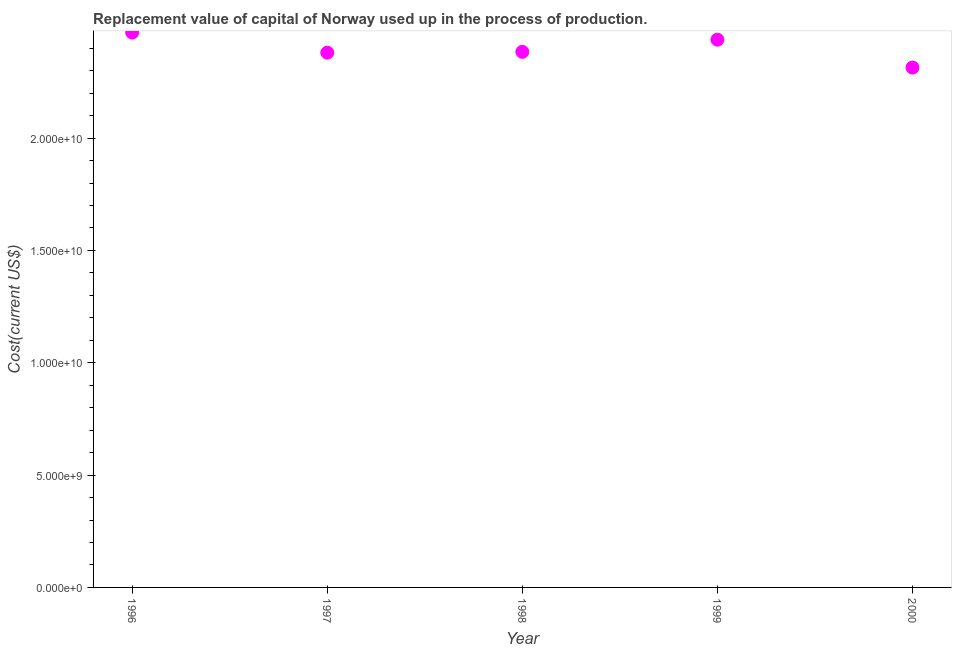What is the consumption of fixed capital in 1997?
Provide a short and direct response. 2.38e+1. Across all years, what is the maximum consumption of fixed capital?
Provide a succinct answer. 2.47e+1. Across all years, what is the minimum consumption of fixed capital?
Your response must be concise. 2.31e+1. What is the sum of the consumption of fixed capital?
Keep it short and to the point. 1.20e+11. What is the difference between the consumption of fixed capital in 1997 and 1998?
Offer a terse response. -3.58e+07. What is the average consumption of fixed capital per year?
Offer a terse response. 2.40e+1. What is the median consumption of fixed capital?
Ensure brevity in your answer.  2.38e+1. In how many years, is the consumption of fixed capital greater than 9000000000 US$?
Provide a short and direct response. 5. What is the ratio of the consumption of fixed capital in 1996 to that in 1998?
Provide a succinct answer. 1.04. Is the consumption of fixed capital in 1999 less than that in 2000?
Provide a succinct answer. No. What is the difference between the highest and the second highest consumption of fixed capital?
Your answer should be compact. 3.17e+08. Is the sum of the consumption of fixed capital in 1996 and 1997 greater than the maximum consumption of fixed capital across all years?
Make the answer very short. Yes. What is the difference between the highest and the lowest consumption of fixed capital?
Keep it short and to the point. 1.56e+09. Does the consumption of fixed capital monotonically increase over the years?
Your answer should be compact. No. How many years are there in the graph?
Provide a succinct answer. 5. What is the difference between two consecutive major ticks on the Y-axis?
Provide a short and direct response. 5.00e+09. Does the graph contain any zero values?
Provide a succinct answer. No. Does the graph contain grids?
Ensure brevity in your answer.  No. What is the title of the graph?
Keep it short and to the point. Replacement value of capital of Norway used up in the process of production. What is the label or title of the X-axis?
Provide a succinct answer. Year. What is the label or title of the Y-axis?
Ensure brevity in your answer.  Cost(current US$). What is the Cost(current US$) in 1996?
Keep it short and to the point. 2.47e+1. What is the Cost(current US$) in 1997?
Offer a very short reply. 2.38e+1. What is the Cost(current US$) in 1998?
Offer a terse response. 2.38e+1. What is the Cost(current US$) in 1999?
Provide a succinct answer. 2.44e+1. What is the Cost(current US$) in 2000?
Give a very brief answer. 2.31e+1. What is the difference between the Cost(current US$) in 1996 and 1997?
Your answer should be compact. 8.94e+08. What is the difference between the Cost(current US$) in 1996 and 1998?
Your response must be concise. 8.58e+08. What is the difference between the Cost(current US$) in 1996 and 1999?
Provide a short and direct response. 3.17e+08. What is the difference between the Cost(current US$) in 1996 and 2000?
Ensure brevity in your answer.  1.56e+09. What is the difference between the Cost(current US$) in 1997 and 1998?
Your answer should be very brief. -3.58e+07. What is the difference between the Cost(current US$) in 1997 and 1999?
Provide a short and direct response. -5.77e+08. What is the difference between the Cost(current US$) in 1997 and 2000?
Offer a very short reply. 6.63e+08. What is the difference between the Cost(current US$) in 1998 and 1999?
Offer a very short reply. -5.41e+08. What is the difference between the Cost(current US$) in 1998 and 2000?
Make the answer very short. 6.98e+08. What is the difference between the Cost(current US$) in 1999 and 2000?
Provide a succinct answer. 1.24e+09. What is the ratio of the Cost(current US$) in 1996 to that in 1997?
Offer a terse response. 1.04. What is the ratio of the Cost(current US$) in 1996 to that in 1998?
Make the answer very short. 1.04. What is the ratio of the Cost(current US$) in 1996 to that in 2000?
Provide a succinct answer. 1.07. What is the ratio of the Cost(current US$) in 1998 to that in 1999?
Give a very brief answer. 0.98. What is the ratio of the Cost(current US$) in 1999 to that in 2000?
Keep it short and to the point. 1.05. 